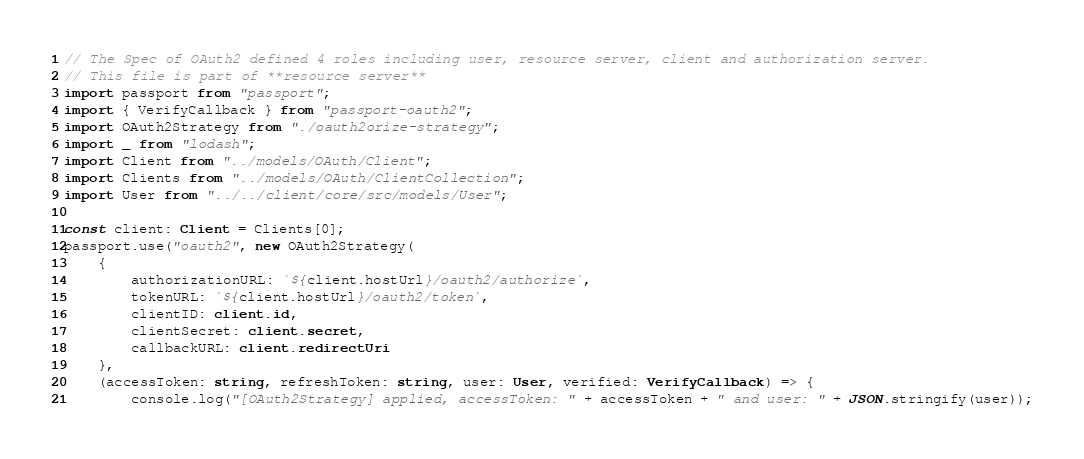<code> <loc_0><loc_0><loc_500><loc_500><_TypeScript_>// The Spec of OAuth2 defined 4 roles including user, resource server, client and authorization server.
// This file is part of **resource server**
import passport from "passport";
import { VerifyCallback } from "passport-oauth2";
import OAuth2Strategy from "./oauth2orize-strategy";
import _ from "lodash";
import Client from "../models/OAuth/Client";
import Clients from "../models/OAuth/ClientCollection";
import User from "../../client/core/src/models/User";

const client: Client = Clients[0];
passport.use("oauth2", new OAuth2Strategy(
    {
        authorizationURL: `${client.hostUrl}/oauth2/authorize`,
        tokenURL: `${client.hostUrl}/oauth2/token`,
        clientID: client.id,
        clientSecret: client.secret,
        callbackURL: client.redirectUri
    },
    (accessToken: string, refreshToken: string, user: User, verified: VerifyCallback) => {
        console.log("[OAuth2Strategy] applied, accessToken: " + accessToken + " and user: " + JSON.stringify(user));</code> 